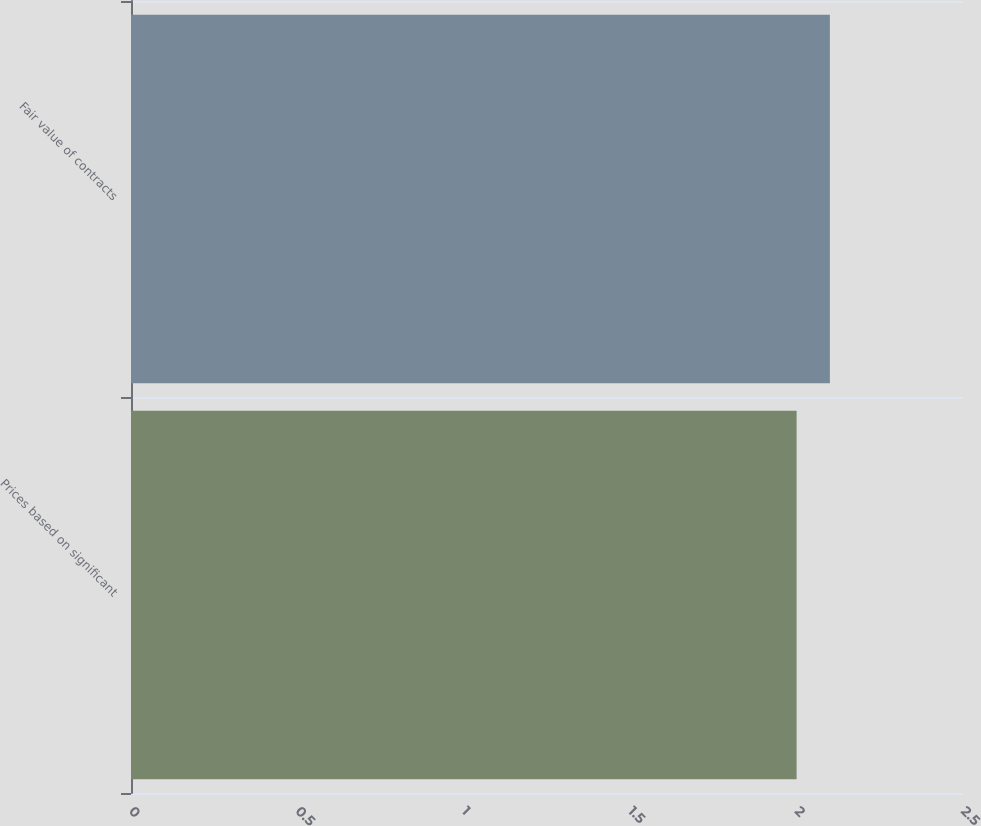Convert chart to OTSL. <chart><loc_0><loc_0><loc_500><loc_500><bar_chart><fcel>Prices based on significant<fcel>Fair value of contracts<nl><fcel>2<fcel>2.1<nl></chart> 